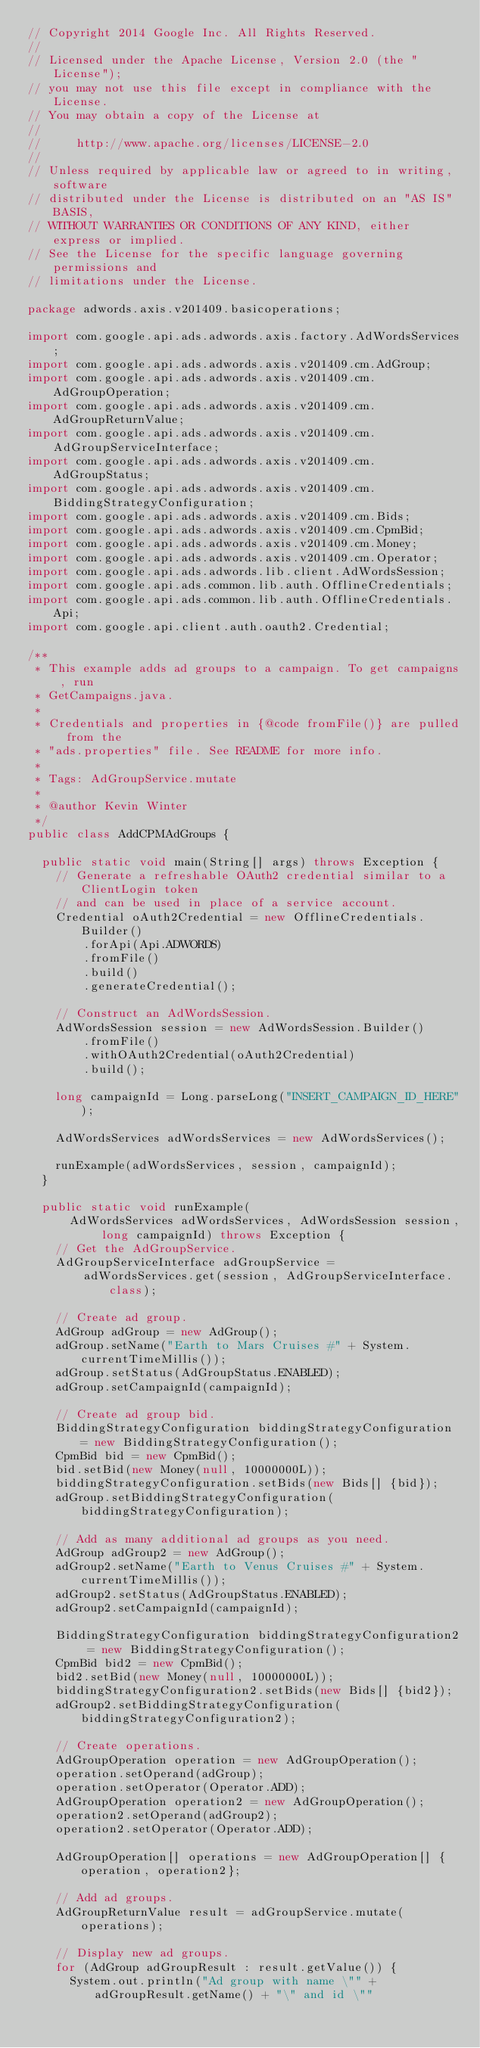<code> <loc_0><loc_0><loc_500><loc_500><_Java_>// Copyright 2014 Google Inc. All Rights Reserved.
//
// Licensed under the Apache License, Version 2.0 (the "License");
// you may not use this file except in compliance with the License.
// You may obtain a copy of the License at
//
//     http://www.apache.org/licenses/LICENSE-2.0
//
// Unless required by applicable law or agreed to in writing, software
// distributed under the License is distributed on an "AS IS" BASIS,
// WITHOUT WARRANTIES OR CONDITIONS OF ANY KIND, either express or implied.
// See the License for the specific language governing permissions and
// limitations under the License.

package adwords.axis.v201409.basicoperations;

import com.google.api.ads.adwords.axis.factory.AdWordsServices;
import com.google.api.ads.adwords.axis.v201409.cm.AdGroup;
import com.google.api.ads.adwords.axis.v201409.cm.AdGroupOperation;
import com.google.api.ads.adwords.axis.v201409.cm.AdGroupReturnValue;
import com.google.api.ads.adwords.axis.v201409.cm.AdGroupServiceInterface;
import com.google.api.ads.adwords.axis.v201409.cm.AdGroupStatus;
import com.google.api.ads.adwords.axis.v201409.cm.BiddingStrategyConfiguration;
import com.google.api.ads.adwords.axis.v201409.cm.Bids;
import com.google.api.ads.adwords.axis.v201409.cm.CpmBid;
import com.google.api.ads.adwords.axis.v201409.cm.Money;
import com.google.api.ads.adwords.axis.v201409.cm.Operator;
import com.google.api.ads.adwords.lib.client.AdWordsSession;
import com.google.api.ads.common.lib.auth.OfflineCredentials;
import com.google.api.ads.common.lib.auth.OfflineCredentials.Api;
import com.google.api.client.auth.oauth2.Credential;

/**
 * This example adds ad groups to a campaign. To get campaigns, run
 * GetCampaigns.java.
 *
 * Credentials and properties in {@code fromFile()} are pulled from the
 * "ads.properties" file. See README for more info.
 *
 * Tags: AdGroupService.mutate
 *
 * @author Kevin Winter
 */
public class AddCPMAdGroups {

  public static void main(String[] args) throws Exception {
    // Generate a refreshable OAuth2 credential similar to a ClientLogin token
    // and can be used in place of a service account.
    Credential oAuth2Credential = new OfflineCredentials.Builder()
        .forApi(Api.ADWORDS)
        .fromFile()
        .build()
        .generateCredential();

    // Construct an AdWordsSession.
    AdWordsSession session = new AdWordsSession.Builder()
        .fromFile()
        .withOAuth2Credential(oAuth2Credential)
        .build();

    long campaignId = Long.parseLong("INSERT_CAMPAIGN_ID_HERE");

    AdWordsServices adWordsServices = new AdWordsServices();

    runExample(adWordsServices, session, campaignId);
  }

  public static void runExample(
      AdWordsServices adWordsServices, AdWordsSession session, long campaignId) throws Exception {
    // Get the AdGroupService.
    AdGroupServiceInterface adGroupService =
        adWordsServices.get(session, AdGroupServiceInterface.class);

    // Create ad group.
    AdGroup adGroup = new AdGroup();
    adGroup.setName("Earth to Mars Cruises #" + System.currentTimeMillis());
    adGroup.setStatus(AdGroupStatus.ENABLED);
    adGroup.setCampaignId(campaignId);

    // Create ad group bid.
    BiddingStrategyConfiguration biddingStrategyConfiguration = new BiddingStrategyConfiguration();
    CpmBid bid = new CpmBid();
    bid.setBid(new Money(null, 10000000L));
    biddingStrategyConfiguration.setBids(new Bids[] {bid});
    adGroup.setBiddingStrategyConfiguration(biddingStrategyConfiguration);

    // Add as many additional ad groups as you need.
    AdGroup adGroup2 = new AdGroup();
    adGroup2.setName("Earth to Venus Cruises #" + System.currentTimeMillis());
    adGroup2.setStatus(AdGroupStatus.ENABLED);
    adGroup2.setCampaignId(campaignId);

    BiddingStrategyConfiguration biddingStrategyConfiguration2 = new BiddingStrategyConfiguration();
    CpmBid bid2 = new CpmBid();
    bid2.setBid(new Money(null, 10000000L));
    biddingStrategyConfiguration2.setBids(new Bids[] {bid2});
    adGroup2.setBiddingStrategyConfiguration(biddingStrategyConfiguration2);

    // Create operations.
    AdGroupOperation operation = new AdGroupOperation();
    operation.setOperand(adGroup);
    operation.setOperator(Operator.ADD);
    AdGroupOperation operation2 = new AdGroupOperation();
    operation2.setOperand(adGroup2);
    operation2.setOperator(Operator.ADD);

    AdGroupOperation[] operations = new AdGroupOperation[] {operation, operation2};

    // Add ad groups.
    AdGroupReturnValue result = adGroupService.mutate(operations);

    // Display new ad groups.
    for (AdGroup adGroupResult : result.getValue()) {
      System.out.println("Ad group with name \"" + adGroupResult.getName() + "\" and id \""</code> 